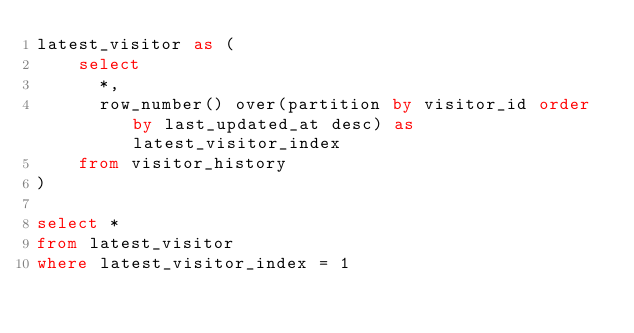<code> <loc_0><loc_0><loc_500><loc_500><_SQL_>latest_visitor as (
    select
      *,
      row_number() over(partition by visitor_id order by last_updated_at desc) as latest_visitor_index
    from visitor_history
)

select *
from latest_visitor
where latest_visitor_index = 1</code> 